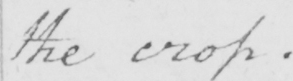Transcribe the text shown in this historical manuscript line. the crop . 